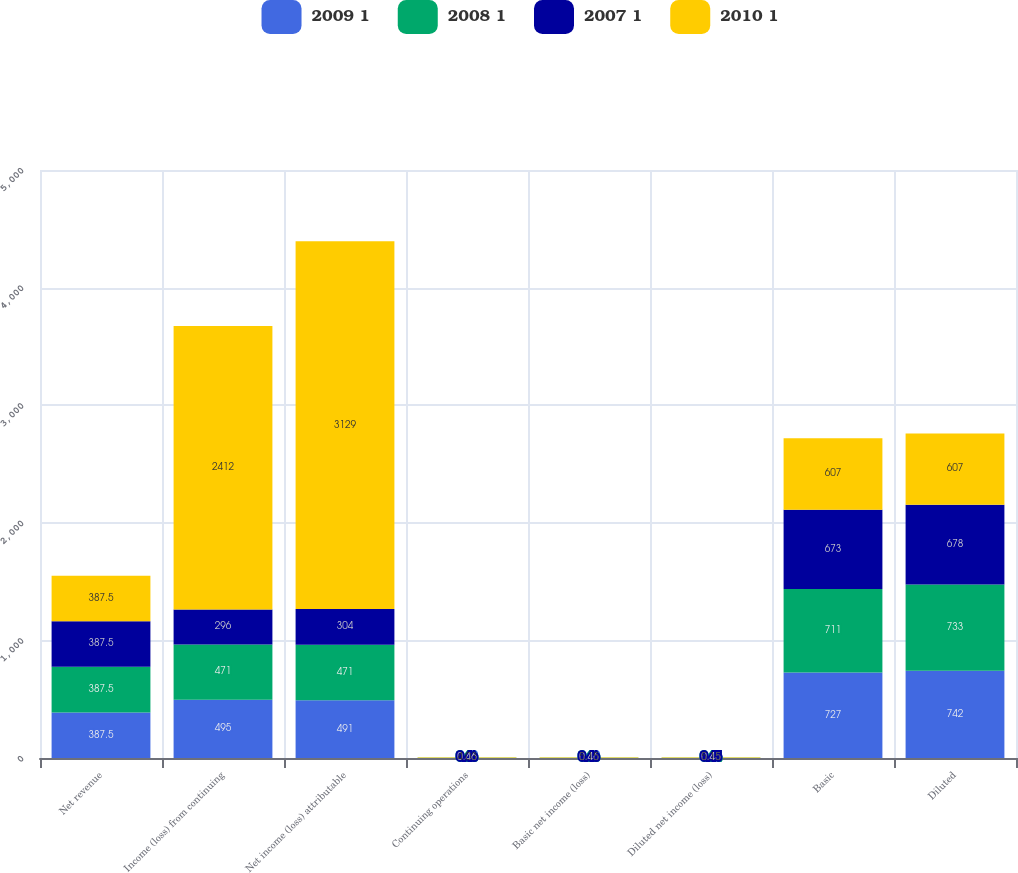Convert chart to OTSL. <chart><loc_0><loc_0><loc_500><loc_500><stacked_bar_chart><ecel><fcel>Net revenue<fcel>Income (loss) from continuing<fcel>Net income (loss) attributable<fcel>Continuing operations<fcel>Basic net income (loss)<fcel>Diluted net income (loss)<fcel>Basic<fcel>Diluted<nl><fcel>2009 1<fcel>387.5<fcel>495<fcel>491<fcel>0.68<fcel>0.68<fcel>0.66<fcel>727<fcel>742<nl><fcel>2008 1<fcel>387.5<fcel>471<fcel>471<fcel>0.66<fcel>0.66<fcel>0.64<fcel>711<fcel>733<nl><fcel>2007 1<fcel>387.5<fcel>296<fcel>304<fcel>0.46<fcel>0.46<fcel>0.45<fcel>673<fcel>678<nl><fcel>2010 1<fcel>387.5<fcel>2412<fcel>3129<fcel>4.03<fcel>5.15<fcel>5.15<fcel>607<fcel>607<nl></chart> 